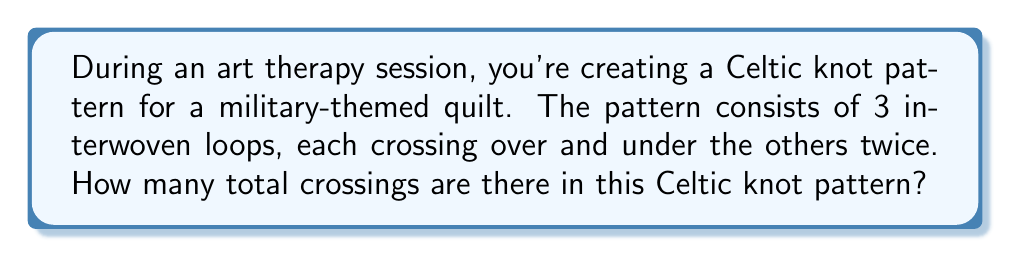Could you help me with this problem? Let's approach this step-by-step:

1) First, we need to understand what constitutes a crossing in a Celtic knot pattern. A crossing occurs each time one strand passes over or under another strand.

2) We are told that there are 3 interwoven loops in the pattern.

3) Each loop crosses over and under the others twice. This means:
   - Loop 1 crosses Loop 2 twice
   - Loop 1 crosses Loop 3 twice
   - Loop 2 crosses Loop 3 twice

4) Let's count the crossings:
   - Loop 1 and Loop 2: 2 crossings
   - Loop 1 and Loop 3: 2 crossings
   - Loop 2 and Loop 3: 2 crossings

5) To calculate the total number of crossings, we sum these up:

   $$ \text{Total crossings} = 2 + 2 + 2 = 6 $$

6) Therefore, there are 6 crossings in total in this Celtic knot pattern.

This type of analysis is similar to calculating the number of edges in a complete graph with 3 vertices, where each edge represents a pair of loops crossing twice.
Answer: 6 crossings 